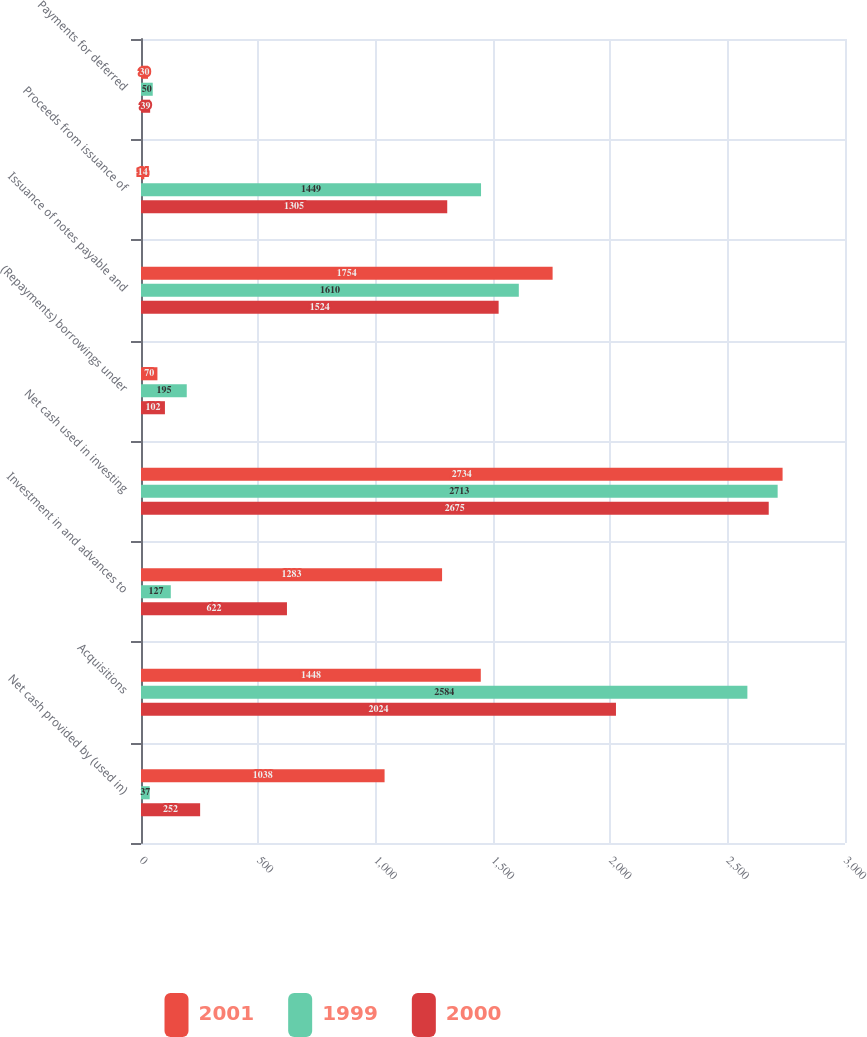Convert chart to OTSL. <chart><loc_0><loc_0><loc_500><loc_500><stacked_bar_chart><ecel><fcel>Net cash provided by (used in)<fcel>Acquisitions<fcel>Investment in and advances to<fcel>Net cash used in investing<fcel>(Repayments) borrowings under<fcel>Issuance of notes payable and<fcel>Proceeds from issuance of<fcel>Payments for deferred<nl><fcel>2001<fcel>1038<fcel>1448<fcel>1283<fcel>2734<fcel>70<fcel>1754<fcel>14<fcel>30<nl><fcel>1999<fcel>37<fcel>2584<fcel>127<fcel>2713<fcel>195<fcel>1610<fcel>1449<fcel>50<nl><fcel>2000<fcel>252<fcel>2024<fcel>622<fcel>2675<fcel>102<fcel>1524<fcel>1305<fcel>39<nl></chart> 